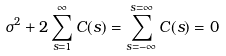Convert formula to latex. <formula><loc_0><loc_0><loc_500><loc_500>\sigma ^ { 2 } + 2 \sum _ { s = 1 } ^ { \infty } C ( s ) = \sum _ { s = - \infty } ^ { s = \infty } C ( s ) = 0</formula> 